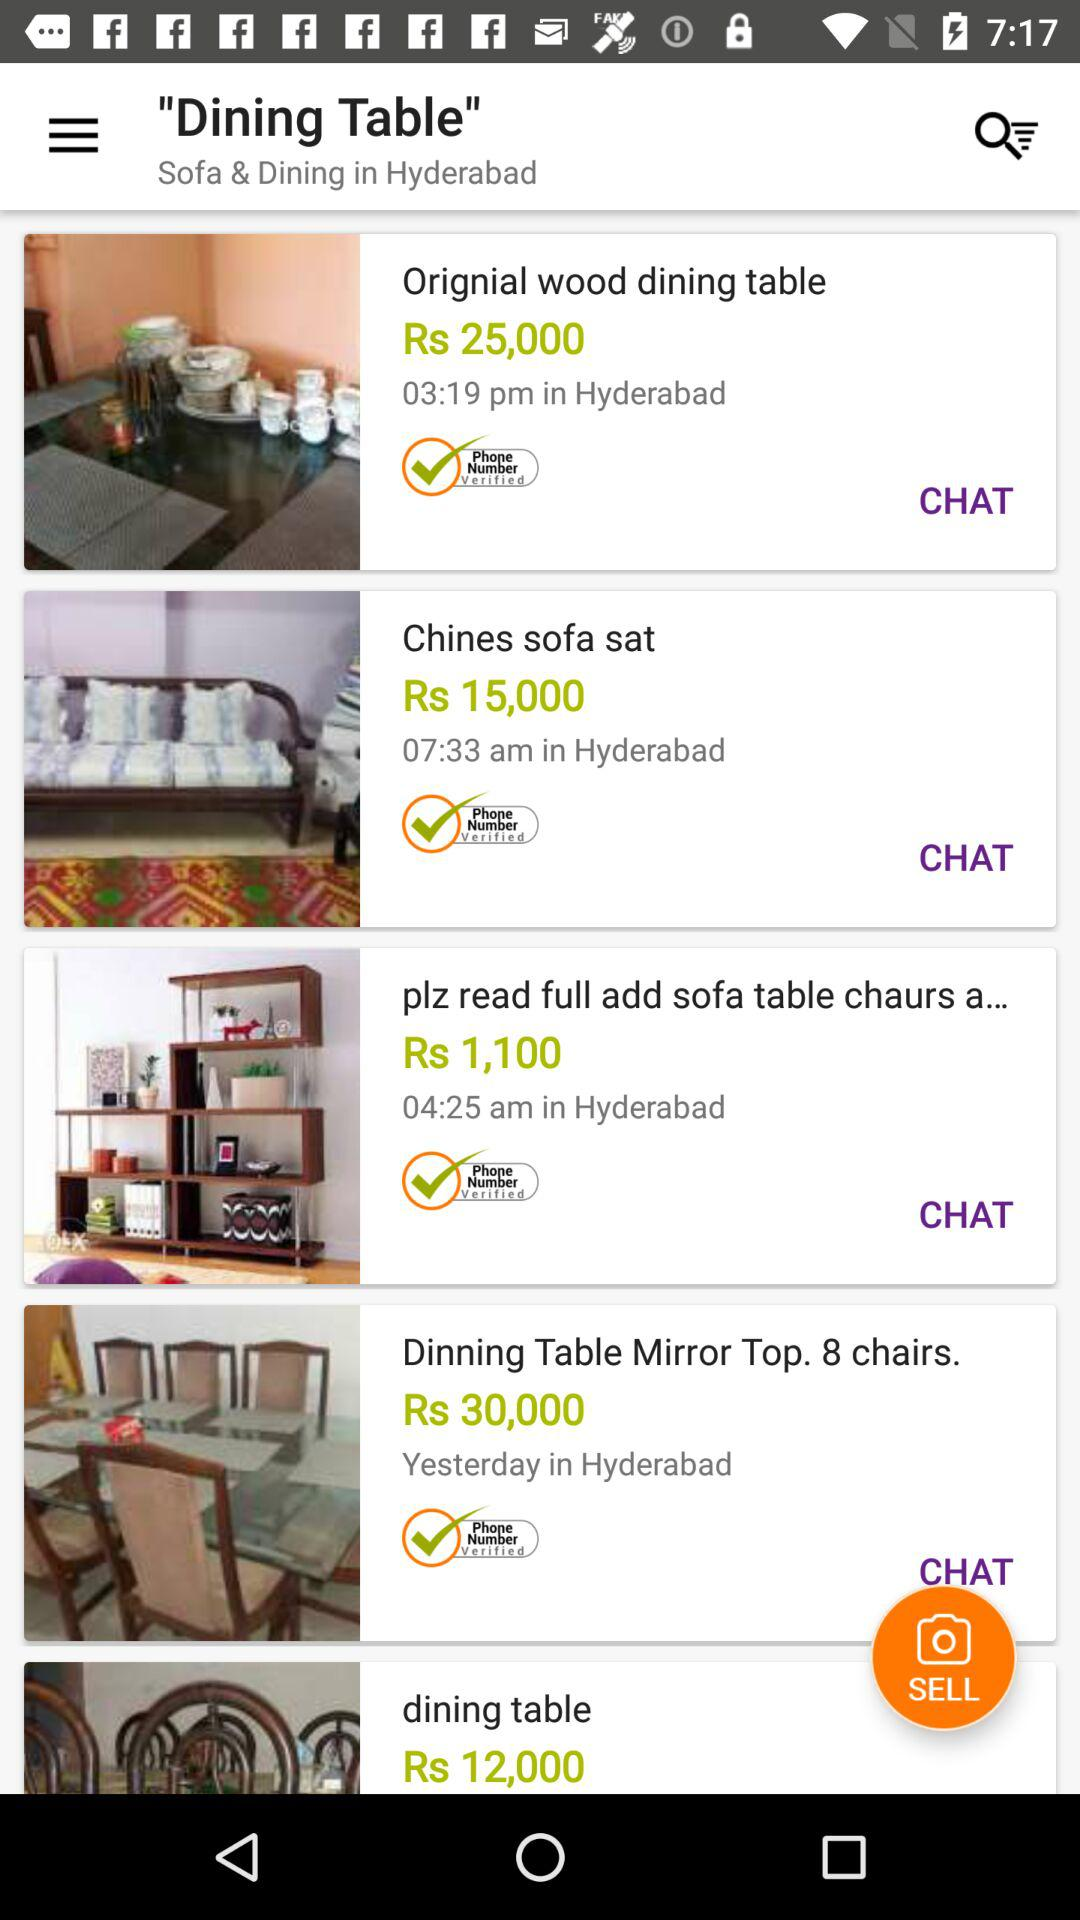Which item is priced the highest? Dinning Table Mirror Top. 8 chairs. 